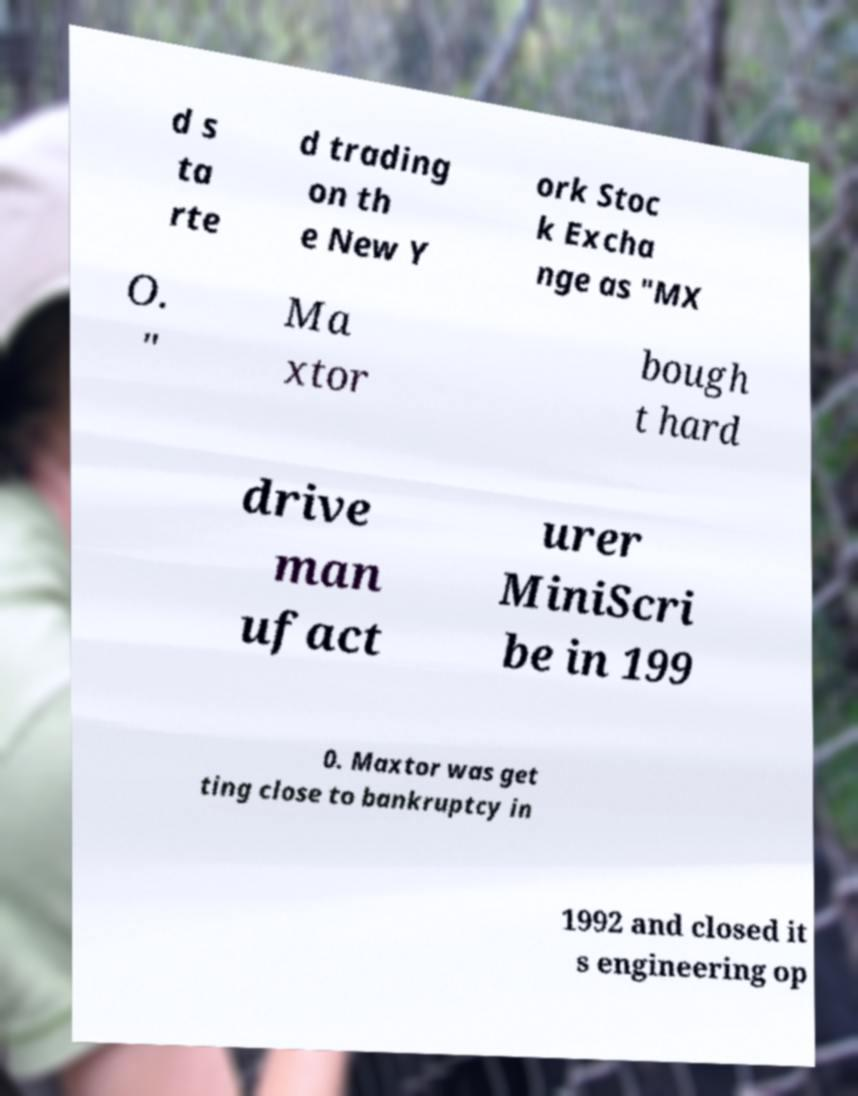What messages or text are displayed in this image? I need them in a readable, typed format. d s ta rte d trading on th e New Y ork Stoc k Excha nge as "MX O. " Ma xtor bough t hard drive man ufact urer MiniScri be in 199 0. Maxtor was get ting close to bankruptcy in 1992 and closed it s engineering op 